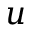Convert formula to latex. <formula><loc_0><loc_0><loc_500><loc_500>u</formula> 